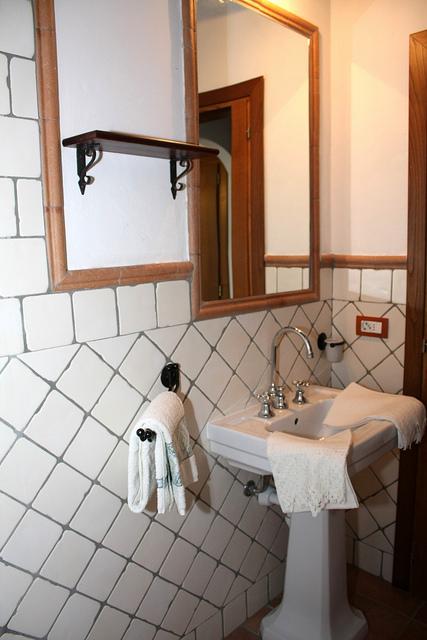Where is the shelf?
Concise answer only. On wall. How many towels are on the sink?
Give a very brief answer. 2. Is there a mirror?
Concise answer only. Yes. 